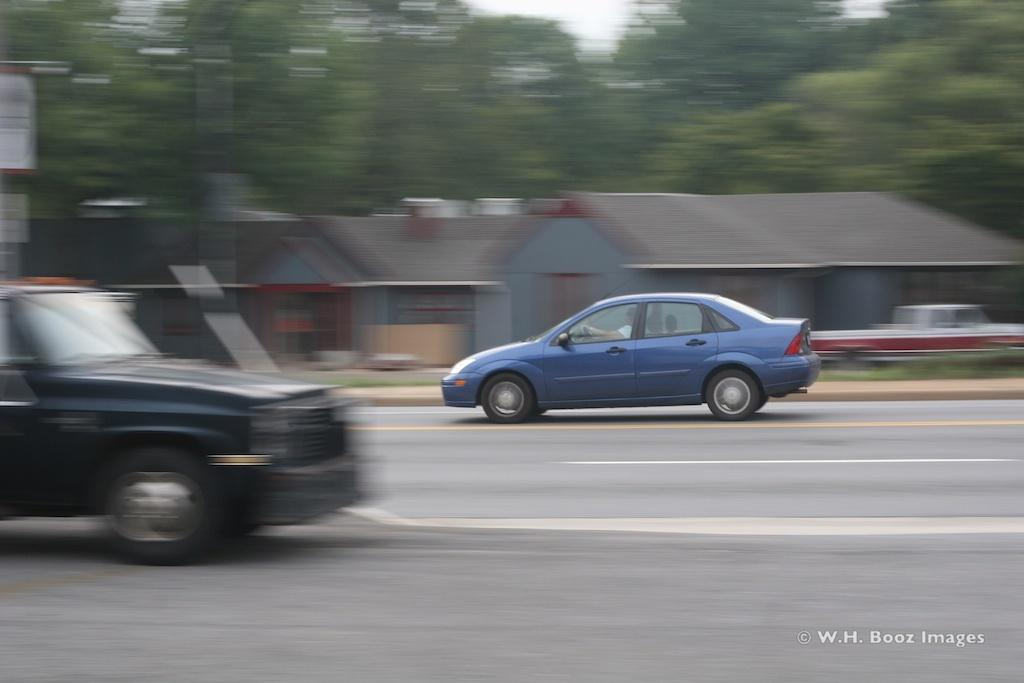What is happening on the road in the image? There are cars moving on the road in the image. What can be seen in the distance in the image? There are houses and trees in the background. What type of vegetation is present on the ground in the image? There is grass on the ground. What type of haircut does the grass have in the image? The grass in the image does not have a haircut, as it is a natural vegetation and not a living being with hair. 